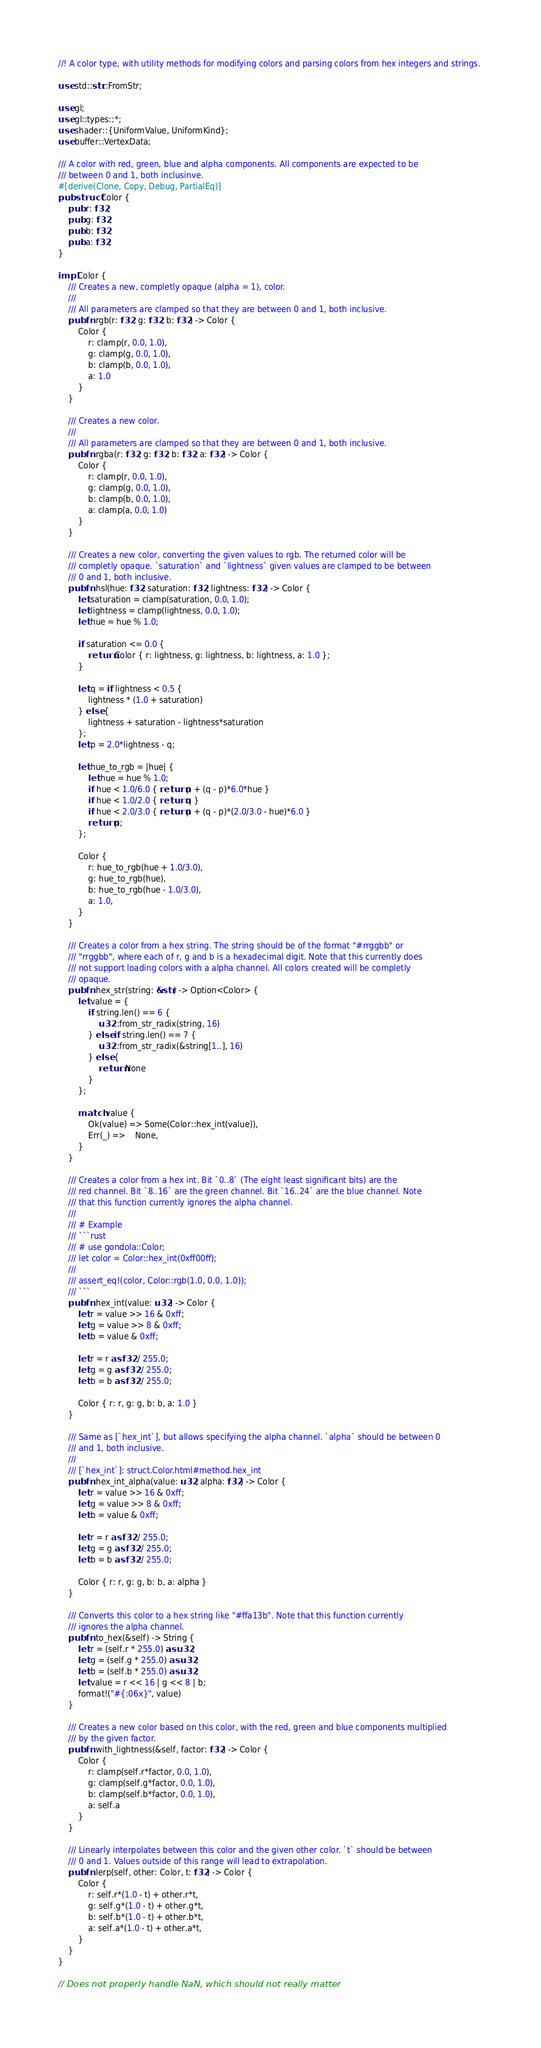<code> <loc_0><loc_0><loc_500><loc_500><_Rust_>
//! A color type, with utility methods for modifying colors and parsing colors from hex integers and strings. 

use std::str::FromStr;

use gl;
use gl::types::*;
use shader::{UniformValue, UniformKind};
use buffer::VertexData;

/// A color with red, green, blue and alpha components. All components are expected to be
/// between 0 and 1, both inclusinve.
#[derive(Clone, Copy, Debug, PartialEq)]
pub struct Color {
    pub r: f32,
    pub g: f32,
    pub b: f32,
    pub a: f32,
}

impl Color {
    /// Creates a new, completly opaque (alpha = 1), color.
    ///
    /// All parameters are clamped so that they are between 0 and 1, both inclusive.
    pub fn rgb(r: f32, g: f32, b: f32) -> Color {
        Color {
            r: clamp(r, 0.0, 1.0),
            g: clamp(g, 0.0, 1.0),
            b: clamp(b, 0.0, 1.0),
            a: 1.0
        }
    }

    /// Creates a new color.
    ///
    /// All parameters are clamped so that they are between 0 and 1, both inclusive.
    pub fn rgba(r: f32, g: f32, b: f32, a: f32) -> Color {
        Color {
            r: clamp(r, 0.0, 1.0),
            g: clamp(g, 0.0, 1.0),
            b: clamp(b, 0.0, 1.0),
            a: clamp(a, 0.0, 1.0)
        }
    }

    /// Creates a new color, converting the given values to rgb. The returned color will be
    /// completly opaque. `saturation` and `lightness` given values are clamped to be between 
    /// 0 and 1, both inclusive.
    pub fn hsl(hue: f32, saturation: f32, lightness: f32) -> Color {
        let saturation = clamp(saturation, 0.0, 1.0);
        let lightness = clamp(lightness, 0.0, 1.0);
        let hue = hue % 1.0;

        if saturation <= 0.0 {
            return Color { r: lightness, g: lightness, b: lightness, a: 1.0 };
        }

        let q = if lightness < 0.5 {
            lightness * (1.0 + saturation)
        } else {
            lightness + saturation - lightness*saturation
        };
        let p = 2.0*lightness - q;

        let hue_to_rgb = |hue| {
            let hue = hue % 1.0;
            if hue < 1.0/6.0 { return p + (q - p)*6.0*hue }
            if hue < 1.0/2.0 { return q }
            if hue < 2.0/3.0 { return p + (q - p)*(2.0/3.0 - hue)*6.0 }
            return p;
        };

        Color { 
            r: hue_to_rgb(hue + 1.0/3.0),
            g: hue_to_rgb(hue),
            b: hue_to_rgb(hue - 1.0/3.0),
            a: 1.0,
        }
    }

    /// Creates a color from a hex string. The string should be of the format "#rrggbb" or
    /// "rrggbb", where each of r, g and b is a hexadecimal digit. Note that this currently does
    /// not support loading colors with a alpha channel. All colors created will be completly
    /// opaque.
    pub fn hex_str(string: &str) -> Option<Color> {
        let value = {
            if string.len() == 6 {
                u32::from_str_radix(string, 16)
            } else if string.len() == 7 {
                u32::from_str_radix(&string[1..], 16)
            } else {
                return None
            }
        };

        match value {
            Ok(value) => Some(Color::hex_int(value)),
            Err(_) =>    None,
        }
    }

    /// Creates a color from a hex int. Bit `0..8` (The eight least significant bits) are the
    /// red channel. Bit `8..16` are the green channel. Bit `16..24` are the blue channel. Note
    /// that this function currently ignores the alpha channel.
    ///
    /// # Example
    /// ```rust
    /// # use gondola::Color;
    /// let color = Color::hex_int(0xff00ff);
    ///
    /// assert_eq!(color, Color::rgb(1.0, 0.0, 1.0));
    /// ```
    pub fn hex_int(value: u32) -> Color {
        let r = value >> 16 & 0xff;
        let g = value >> 8 & 0xff;
        let b = value & 0xff;

        let r = r as f32 / 255.0;
        let g = g as f32 / 255.0;
        let b = b as f32 / 255.0;

        Color { r: r, g: g, b: b, a: 1.0 }
    } 

    /// Same as [`hex_int`], but allows specifying the alpha channel. `alpha` should be between 0
    /// and 1, both inclusive.
    ///
    /// [`hex_int`]: struct.Color.html#method.hex_int
    pub fn hex_int_alpha(value: u32, alpha: f32) -> Color {
        let r = value >> 16 & 0xff;
        let g = value >> 8 & 0xff;
        let b = value & 0xff;

        let r = r as f32 / 255.0;
        let g = g as f32 / 255.0;
        let b = b as f32 / 255.0;

        Color { r: r, g: g, b: b, a: alpha }
    }

    /// Converts this color to a hex string like "#ffa13b". Note that this function currently
    /// ignores the alpha channel.
    pub fn to_hex(&self) -> String {
        let r = (self.r * 255.0) as u32;
        let g = (self.g * 255.0) as u32;
        let b = (self.b * 255.0) as u32;
        let value = r << 16 | g << 8 | b;
        format!("#{:06x}", value)
    }

    /// Creates a new color based on this color, with the red, green and blue components multiplied
    /// by the given factor.
    pub fn with_lightness(&self, factor: f32) -> Color {
        Color {
            r: clamp(self.r*factor, 0.0, 1.0),
            g: clamp(self.g*factor, 0.0, 1.0),
            b: clamp(self.b*factor, 0.0, 1.0),
            a: self.a
        }
    }

    /// Linearly interpolates between this color and the given other color. `t` should be between
    /// 0 and 1. Values outside of this range will lead to extrapolation.
    pub fn lerp(self, other: Color, t: f32) -> Color {
        Color {
            r: self.r*(1.0 - t) + other.r*t,
            g: self.g*(1.0 - t) + other.g*t,
            b: self.b*(1.0 - t) + other.b*t,
            a: self.a*(1.0 - t) + other.a*t,
        }
    }
}

// Does not properly handle NaN, which should not really matter</code> 